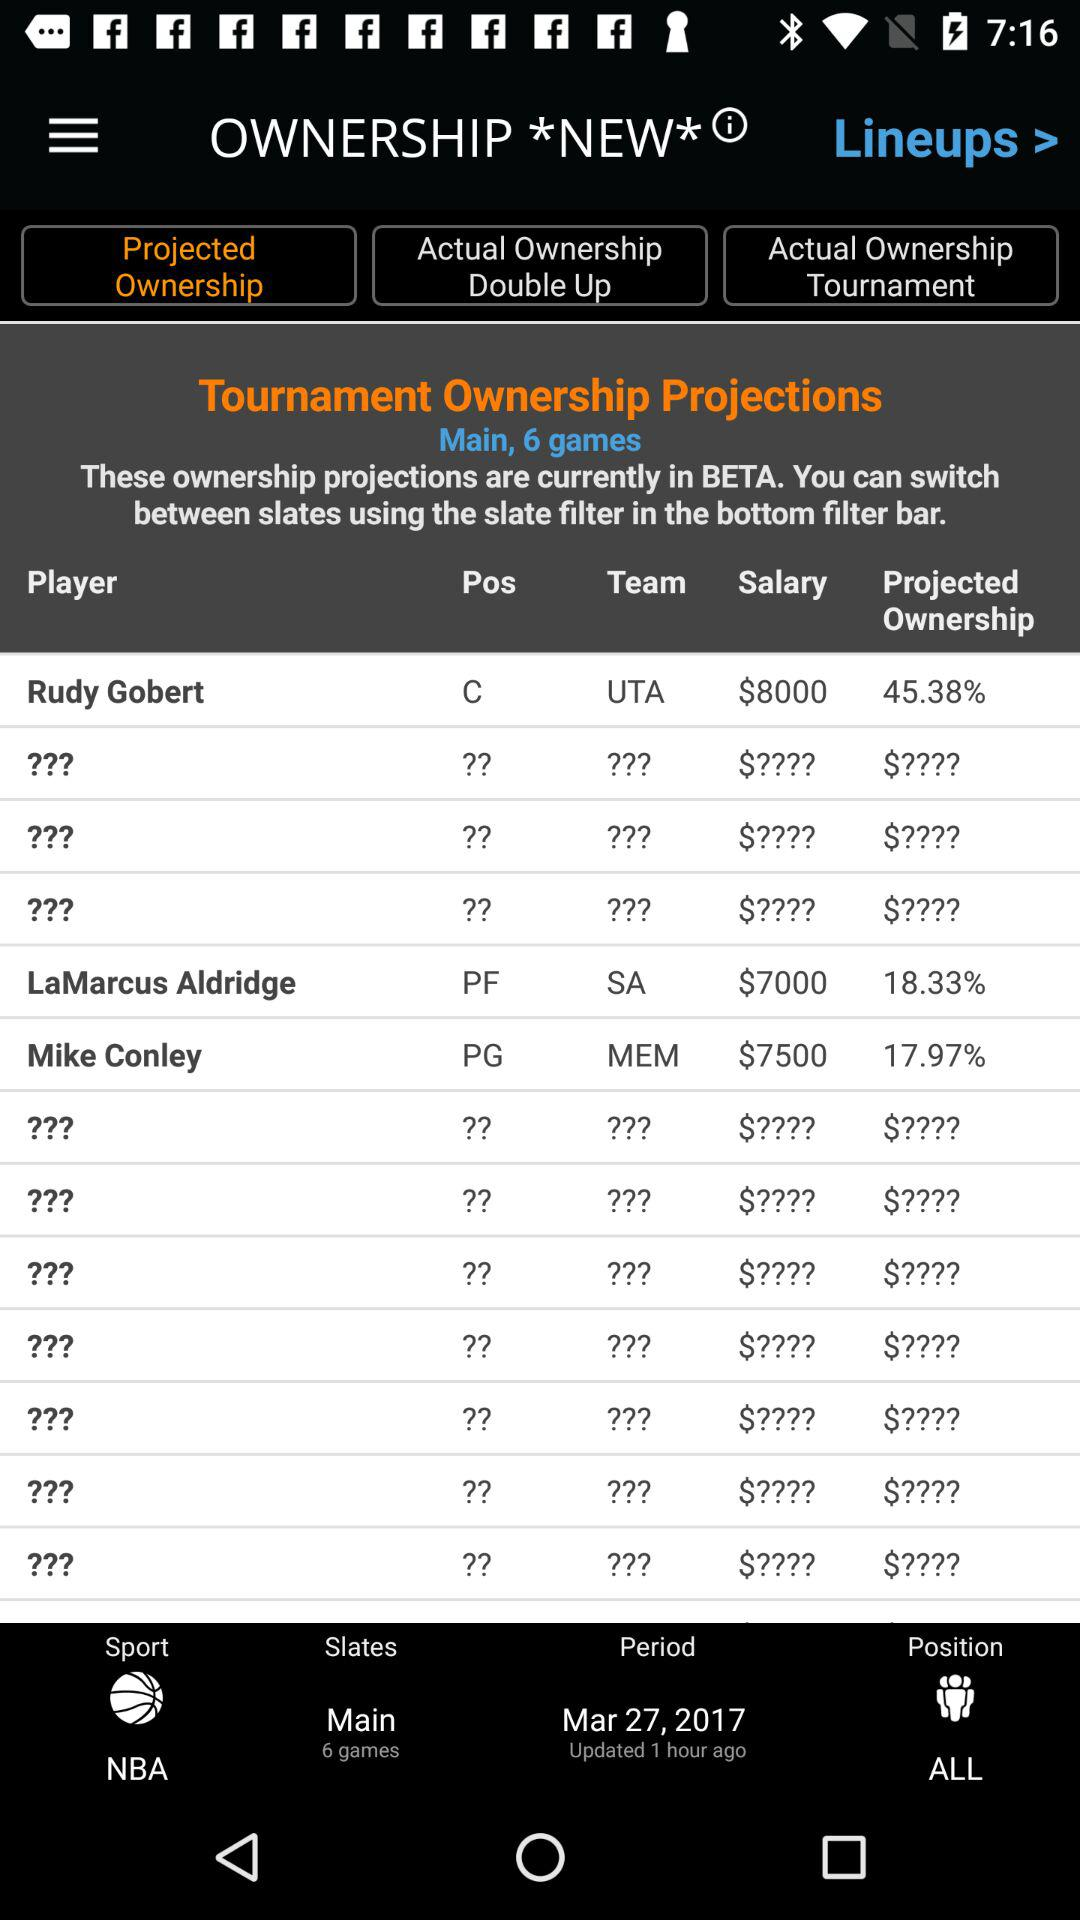Which tab is selected? The selected tab is "Projected Ownership". 